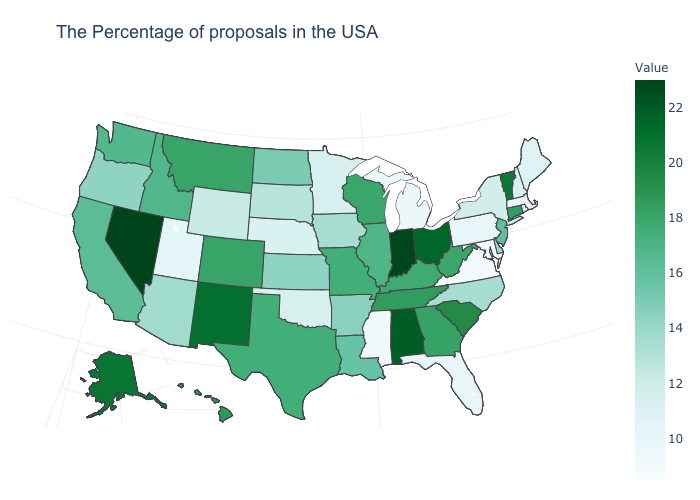Does Virginia have the highest value in the South?
Give a very brief answer. No. Which states have the highest value in the USA?
Write a very short answer. Nevada. Which states have the lowest value in the USA?
Write a very short answer. Maryland. Which states have the highest value in the USA?
Keep it brief. Nevada. Among the states that border Arkansas , which have the highest value?
Concise answer only. Tennessee. Does Maryland have the lowest value in the USA?
Short answer required. Yes. 